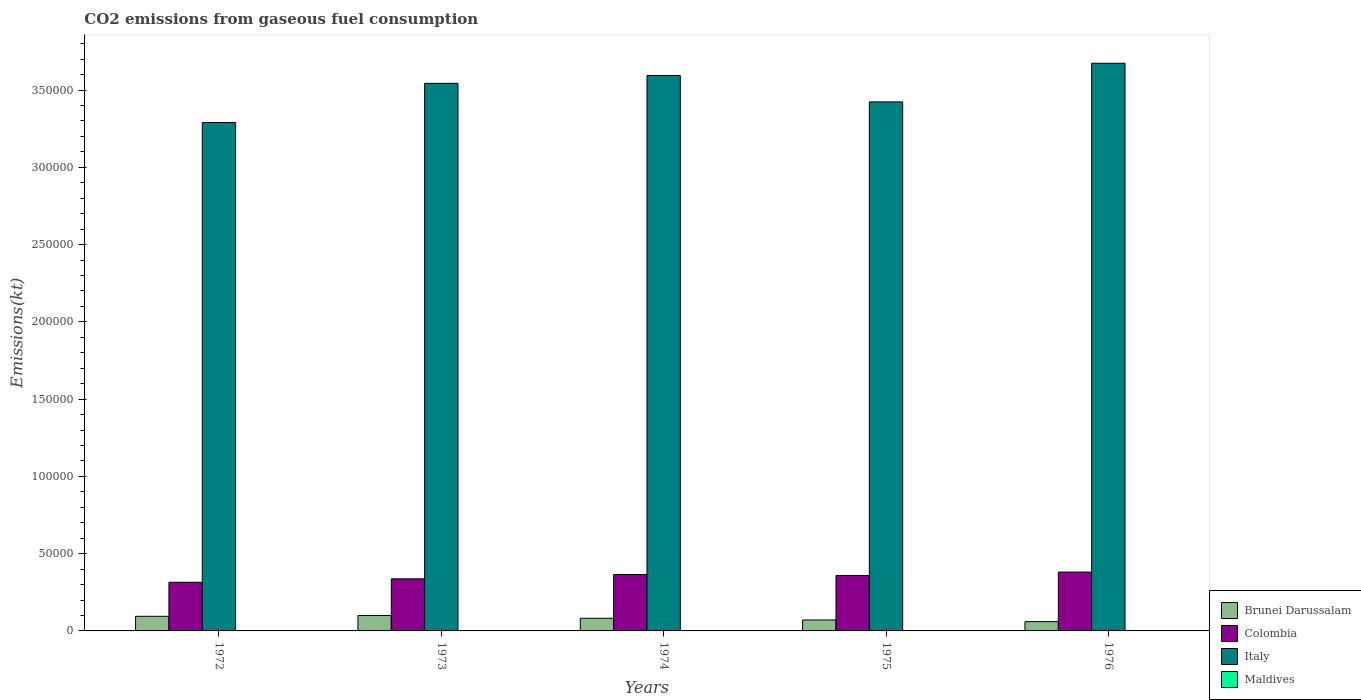How many different coloured bars are there?
Your answer should be very brief. 4. How many groups of bars are there?
Provide a succinct answer. 5. Are the number of bars on each tick of the X-axis equal?
Give a very brief answer. Yes. How many bars are there on the 2nd tick from the left?
Make the answer very short. 4. What is the label of the 5th group of bars from the left?
Offer a terse response. 1976. In how many cases, is the number of bars for a given year not equal to the number of legend labels?
Offer a terse response. 0. What is the amount of CO2 emitted in Brunei Darussalam in 1973?
Offer a very short reply. 9981.57. Across all years, what is the maximum amount of CO2 emitted in Maldives?
Provide a short and direct response. 11. Across all years, what is the minimum amount of CO2 emitted in Italy?
Provide a short and direct response. 3.29e+05. In which year was the amount of CO2 emitted in Maldives maximum?
Provide a short and direct response. 1976. In which year was the amount of CO2 emitted in Maldives minimum?
Your response must be concise. 1972. What is the total amount of CO2 emitted in Colombia in the graph?
Your answer should be very brief. 1.76e+05. What is the difference between the amount of CO2 emitted in Colombia in 1972 and that in 1974?
Your response must be concise. -4998.12. What is the difference between the amount of CO2 emitted in Italy in 1973 and the amount of CO2 emitted in Colombia in 1975?
Offer a very short reply. 3.18e+05. What is the average amount of CO2 emitted in Maldives per year?
Your response must be concise. 5.87. In the year 1975, what is the difference between the amount of CO2 emitted in Brunei Darussalam and amount of CO2 emitted in Italy?
Make the answer very short. -3.35e+05. What is the ratio of the amount of CO2 emitted in Italy in 1972 to that in 1974?
Offer a very short reply. 0.92. Is the amount of CO2 emitted in Maldives in 1973 less than that in 1975?
Your answer should be compact. Yes. Is the difference between the amount of CO2 emitted in Brunei Darussalam in 1973 and 1975 greater than the difference between the amount of CO2 emitted in Italy in 1973 and 1975?
Your answer should be compact. No. What is the difference between the highest and the second highest amount of CO2 emitted in Maldives?
Keep it short and to the point. 3.67. What is the difference between the highest and the lowest amount of CO2 emitted in Italy?
Ensure brevity in your answer.  3.83e+04. In how many years, is the amount of CO2 emitted in Maldives greater than the average amount of CO2 emitted in Maldives taken over all years?
Your answer should be very brief. 2. Is it the case that in every year, the sum of the amount of CO2 emitted in Italy and amount of CO2 emitted in Brunei Darussalam is greater than the sum of amount of CO2 emitted in Maldives and amount of CO2 emitted in Colombia?
Your answer should be very brief. No. What does the 1st bar from the left in 1976 represents?
Provide a succinct answer. Brunei Darussalam. What does the 4th bar from the right in 1974 represents?
Offer a very short reply. Brunei Darussalam. Are all the bars in the graph horizontal?
Ensure brevity in your answer.  No. How many years are there in the graph?
Offer a very short reply. 5. Are the values on the major ticks of Y-axis written in scientific E-notation?
Offer a very short reply. No. Does the graph contain any zero values?
Provide a short and direct response. No. Does the graph contain grids?
Your answer should be compact. No. Where does the legend appear in the graph?
Give a very brief answer. Bottom right. How many legend labels are there?
Offer a very short reply. 4. How are the legend labels stacked?
Make the answer very short. Vertical. What is the title of the graph?
Provide a succinct answer. CO2 emissions from gaseous fuel consumption. What is the label or title of the X-axis?
Provide a short and direct response. Years. What is the label or title of the Y-axis?
Your response must be concise. Emissions(kt). What is the Emissions(kt) of Brunei Darussalam in 1972?
Your answer should be compact. 9460.86. What is the Emissions(kt) of Colombia in 1972?
Give a very brief answer. 3.15e+04. What is the Emissions(kt) of Italy in 1972?
Offer a very short reply. 3.29e+05. What is the Emissions(kt) of Maldives in 1972?
Provide a succinct answer. 3.67. What is the Emissions(kt) in Brunei Darussalam in 1973?
Give a very brief answer. 9981.57. What is the Emissions(kt) in Colombia in 1973?
Your response must be concise. 3.37e+04. What is the Emissions(kt) of Italy in 1973?
Provide a short and direct response. 3.54e+05. What is the Emissions(kt) in Maldives in 1973?
Give a very brief answer. 3.67. What is the Emissions(kt) in Brunei Darussalam in 1974?
Give a very brief answer. 8184.74. What is the Emissions(kt) of Colombia in 1974?
Offer a very short reply. 3.65e+04. What is the Emissions(kt) in Italy in 1974?
Your response must be concise. 3.59e+05. What is the Emissions(kt) of Maldives in 1974?
Your response must be concise. 3.67. What is the Emissions(kt) in Brunei Darussalam in 1975?
Make the answer very short. 7080.98. What is the Emissions(kt) of Colombia in 1975?
Give a very brief answer. 3.59e+04. What is the Emissions(kt) in Italy in 1975?
Your answer should be compact. 3.42e+05. What is the Emissions(kt) in Maldives in 1975?
Provide a succinct answer. 7.33. What is the Emissions(kt) of Brunei Darussalam in 1976?
Provide a short and direct response. 6024.88. What is the Emissions(kt) of Colombia in 1976?
Keep it short and to the point. 3.81e+04. What is the Emissions(kt) in Italy in 1976?
Your response must be concise. 3.67e+05. What is the Emissions(kt) of Maldives in 1976?
Keep it short and to the point. 11. Across all years, what is the maximum Emissions(kt) in Brunei Darussalam?
Your answer should be compact. 9981.57. Across all years, what is the maximum Emissions(kt) in Colombia?
Ensure brevity in your answer.  3.81e+04. Across all years, what is the maximum Emissions(kt) in Italy?
Offer a terse response. 3.67e+05. Across all years, what is the maximum Emissions(kt) of Maldives?
Make the answer very short. 11. Across all years, what is the minimum Emissions(kt) of Brunei Darussalam?
Your response must be concise. 6024.88. Across all years, what is the minimum Emissions(kt) in Colombia?
Your response must be concise. 3.15e+04. Across all years, what is the minimum Emissions(kt) of Italy?
Keep it short and to the point. 3.29e+05. Across all years, what is the minimum Emissions(kt) in Maldives?
Give a very brief answer. 3.67. What is the total Emissions(kt) of Brunei Darussalam in the graph?
Ensure brevity in your answer.  4.07e+04. What is the total Emissions(kt) of Colombia in the graph?
Ensure brevity in your answer.  1.76e+05. What is the total Emissions(kt) of Italy in the graph?
Provide a succinct answer. 1.75e+06. What is the total Emissions(kt) of Maldives in the graph?
Your response must be concise. 29.34. What is the difference between the Emissions(kt) in Brunei Darussalam in 1972 and that in 1973?
Provide a short and direct response. -520.71. What is the difference between the Emissions(kt) in Colombia in 1972 and that in 1973?
Provide a short and direct response. -2218.53. What is the difference between the Emissions(kt) of Italy in 1972 and that in 1973?
Give a very brief answer. -2.53e+04. What is the difference between the Emissions(kt) in Brunei Darussalam in 1972 and that in 1974?
Keep it short and to the point. 1276.12. What is the difference between the Emissions(kt) of Colombia in 1972 and that in 1974?
Provide a succinct answer. -4998.12. What is the difference between the Emissions(kt) of Italy in 1972 and that in 1974?
Ensure brevity in your answer.  -3.04e+04. What is the difference between the Emissions(kt) of Maldives in 1972 and that in 1974?
Ensure brevity in your answer.  0. What is the difference between the Emissions(kt) in Brunei Darussalam in 1972 and that in 1975?
Ensure brevity in your answer.  2379.88. What is the difference between the Emissions(kt) in Colombia in 1972 and that in 1975?
Your answer should be compact. -4415.07. What is the difference between the Emissions(kt) in Italy in 1972 and that in 1975?
Your response must be concise. -1.33e+04. What is the difference between the Emissions(kt) of Maldives in 1972 and that in 1975?
Offer a very short reply. -3.67. What is the difference between the Emissions(kt) of Brunei Darussalam in 1972 and that in 1976?
Your response must be concise. 3435.98. What is the difference between the Emissions(kt) in Colombia in 1972 and that in 1976?
Offer a terse response. -6607.93. What is the difference between the Emissions(kt) of Italy in 1972 and that in 1976?
Provide a succinct answer. -3.83e+04. What is the difference between the Emissions(kt) in Maldives in 1972 and that in 1976?
Make the answer very short. -7.33. What is the difference between the Emissions(kt) of Brunei Darussalam in 1973 and that in 1974?
Offer a terse response. 1796.83. What is the difference between the Emissions(kt) in Colombia in 1973 and that in 1974?
Ensure brevity in your answer.  -2779.59. What is the difference between the Emissions(kt) in Italy in 1973 and that in 1974?
Your response must be concise. -5086.13. What is the difference between the Emissions(kt) in Brunei Darussalam in 1973 and that in 1975?
Your answer should be very brief. 2900.6. What is the difference between the Emissions(kt) in Colombia in 1973 and that in 1975?
Your answer should be compact. -2196.53. What is the difference between the Emissions(kt) of Italy in 1973 and that in 1975?
Give a very brief answer. 1.20e+04. What is the difference between the Emissions(kt) in Maldives in 1973 and that in 1975?
Provide a succinct answer. -3.67. What is the difference between the Emissions(kt) in Brunei Darussalam in 1973 and that in 1976?
Offer a very short reply. 3956.69. What is the difference between the Emissions(kt) in Colombia in 1973 and that in 1976?
Your answer should be very brief. -4389.4. What is the difference between the Emissions(kt) of Italy in 1973 and that in 1976?
Keep it short and to the point. -1.30e+04. What is the difference between the Emissions(kt) in Maldives in 1973 and that in 1976?
Your answer should be very brief. -7.33. What is the difference between the Emissions(kt) of Brunei Darussalam in 1974 and that in 1975?
Make the answer very short. 1103.77. What is the difference between the Emissions(kt) in Colombia in 1974 and that in 1975?
Your answer should be compact. 583.05. What is the difference between the Emissions(kt) of Italy in 1974 and that in 1975?
Make the answer very short. 1.71e+04. What is the difference between the Emissions(kt) of Maldives in 1974 and that in 1975?
Provide a succinct answer. -3.67. What is the difference between the Emissions(kt) in Brunei Darussalam in 1974 and that in 1976?
Keep it short and to the point. 2159.86. What is the difference between the Emissions(kt) of Colombia in 1974 and that in 1976?
Offer a very short reply. -1609.81. What is the difference between the Emissions(kt) of Italy in 1974 and that in 1976?
Your answer should be very brief. -7906.05. What is the difference between the Emissions(kt) of Maldives in 1974 and that in 1976?
Offer a terse response. -7.33. What is the difference between the Emissions(kt) of Brunei Darussalam in 1975 and that in 1976?
Ensure brevity in your answer.  1056.1. What is the difference between the Emissions(kt) in Colombia in 1975 and that in 1976?
Offer a very short reply. -2192.87. What is the difference between the Emissions(kt) of Italy in 1975 and that in 1976?
Make the answer very short. -2.50e+04. What is the difference between the Emissions(kt) in Maldives in 1975 and that in 1976?
Offer a very short reply. -3.67. What is the difference between the Emissions(kt) in Brunei Darussalam in 1972 and the Emissions(kt) in Colombia in 1973?
Keep it short and to the point. -2.42e+04. What is the difference between the Emissions(kt) in Brunei Darussalam in 1972 and the Emissions(kt) in Italy in 1973?
Make the answer very short. -3.45e+05. What is the difference between the Emissions(kt) in Brunei Darussalam in 1972 and the Emissions(kt) in Maldives in 1973?
Offer a terse response. 9457.19. What is the difference between the Emissions(kt) of Colombia in 1972 and the Emissions(kt) of Italy in 1973?
Your answer should be very brief. -3.23e+05. What is the difference between the Emissions(kt) of Colombia in 1972 and the Emissions(kt) of Maldives in 1973?
Your answer should be compact. 3.15e+04. What is the difference between the Emissions(kt) in Italy in 1972 and the Emissions(kt) in Maldives in 1973?
Ensure brevity in your answer.  3.29e+05. What is the difference between the Emissions(kt) in Brunei Darussalam in 1972 and the Emissions(kt) in Colombia in 1974?
Provide a succinct answer. -2.70e+04. What is the difference between the Emissions(kt) in Brunei Darussalam in 1972 and the Emissions(kt) in Italy in 1974?
Keep it short and to the point. -3.50e+05. What is the difference between the Emissions(kt) of Brunei Darussalam in 1972 and the Emissions(kt) of Maldives in 1974?
Provide a succinct answer. 9457.19. What is the difference between the Emissions(kt) in Colombia in 1972 and the Emissions(kt) in Italy in 1974?
Make the answer very short. -3.28e+05. What is the difference between the Emissions(kt) of Colombia in 1972 and the Emissions(kt) of Maldives in 1974?
Your answer should be compact. 3.15e+04. What is the difference between the Emissions(kt) of Italy in 1972 and the Emissions(kt) of Maldives in 1974?
Offer a very short reply. 3.29e+05. What is the difference between the Emissions(kt) in Brunei Darussalam in 1972 and the Emissions(kt) in Colombia in 1975?
Offer a very short reply. -2.64e+04. What is the difference between the Emissions(kt) in Brunei Darussalam in 1972 and the Emissions(kt) in Italy in 1975?
Offer a very short reply. -3.33e+05. What is the difference between the Emissions(kt) in Brunei Darussalam in 1972 and the Emissions(kt) in Maldives in 1975?
Your answer should be very brief. 9453.53. What is the difference between the Emissions(kt) in Colombia in 1972 and the Emissions(kt) in Italy in 1975?
Keep it short and to the point. -3.11e+05. What is the difference between the Emissions(kt) of Colombia in 1972 and the Emissions(kt) of Maldives in 1975?
Your answer should be compact. 3.15e+04. What is the difference between the Emissions(kt) of Italy in 1972 and the Emissions(kt) of Maldives in 1975?
Keep it short and to the point. 3.29e+05. What is the difference between the Emissions(kt) of Brunei Darussalam in 1972 and the Emissions(kt) of Colombia in 1976?
Keep it short and to the point. -2.86e+04. What is the difference between the Emissions(kt) of Brunei Darussalam in 1972 and the Emissions(kt) of Italy in 1976?
Offer a terse response. -3.58e+05. What is the difference between the Emissions(kt) of Brunei Darussalam in 1972 and the Emissions(kt) of Maldives in 1976?
Your response must be concise. 9449.86. What is the difference between the Emissions(kt) in Colombia in 1972 and the Emissions(kt) in Italy in 1976?
Provide a short and direct response. -3.36e+05. What is the difference between the Emissions(kt) of Colombia in 1972 and the Emissions(kt) of Maldives in 1976?
Make the answer very short. 3.15e+04. What is the difference between the Emissions(kt) in Italy in 1972 and the Emissions(kt) in Maldives in 1976?
Your response must be concise. 3.29e+05. What is the difference between the Emissions(kt) of Brunei Darussalam in 1973 and the Emissions(kt) of Colombia in 1974?
Make the answer very short. -2.65e+04. What is the difference between the Emissions(kt) of Brunei Darussalam in 1973 and the Emissions(kt) of Italy in 1974?
Provide a succinct answer. -3.49e+05. What is the difference between the Emissions(kt) in Brunei Darussalam in 1973 and the Emissions(kt) in Maldives in 1974?
Make the answer very short. 9977.91. What is the difference between the Emissions(kt) of Colombia in 1973 and the Emissions(kt) of Italy in 1974?
Offer a very short reply. -3.26e+05. What is the difference between the Emissions(kt) of Colombia in 1973 and the Emissions(kt) of Maldives in 1974?
Your answer should be very brief. 3.37e+04. What is the difference between the Emissions(kt) in Italy in 1973 and the Emissions(kt) in Maldives in 1974?
Offer a very short reply. 3.54e+05. What is the difference between the Emissions(kt) of Brunei Darussalam in 1973 and the Emissions(kt) of Colombia in 1975?
Give a very brief answer. -2.59e+04. What is the difference between the Emissions(kt) in Brunei Darussalam in 1973 and the Emissions(kt) in Italy in 1975?
Your response must be concise. -3.32e+05. What is the difference between the Emissions(kt) in Brunei Darussalam in 1973 and the Emissions(kt) in Maldives in 1975?
Provide a short and direct response. 9974.24. What is the difference between the Emissions(kt) in Colombia in 1973 and the Emissions(kt) in Italy in 1975?
Make the answer very short. -3.09e+05. What is the difference between the Emissions(kt) in Colombia in 1973 and the Emissions(kt) in Maldives in 1975?
Provide a short and direct response. 3.37e+04. What is the difference between the Emissions(kt) in Italy in 1973 and the Emissions(kt) in Maldives in 1975?
Give a very brief answer. 3.54e+05. What is the difference between the Emissions(kt) in Brunei Darussalam in 1973 and the Emissions(kt) in Colombia in 1976?
Your response must be concise. -2.81e+04. What is the difference between the Emissions(kt) in Brunei Darussalam in 1973 and the Emissions(kt) in Italy in 1976?
Give a very brief answer. -3.57e+05. What is the difference between the Emissions(kt) of Brunei Darussalam in 1973 and the Emissions(kt) of Maldives in 1976?
Offer a very short reply. 9970.57. What is the difference between the Emissions(kt) of Colombia in 1973 and the Emissions(kt) of Italy in 1976?
Provide a short and direct response. -3.34e+05. What is the difference between the Emissions(kt) of Colombia in 1973 and the Emissions(kt) of Maldives in 1976?
Provide a succinct answer. 3.37e+04. What is the difference between the Emissions(kt) in Italy in 1973 and the Emissions(kt) in Maldives in 1976?
Your answer should be compact. 3.54e+05. What is the difference between the Emissions(kt) in Brunei Darussalam in 1974 and the Emissions(kt) in Colombia in 1975?
Your response must be concise. -2.77e+04. What is the difference between the Emissions(kt) of Brunei Darussalam in 1974 and the Emissions(kt) of Italy in 1975?
Keep it short and to the point. -3.34e+05. What is the difference between the Emissions(kt) of Brunei Darussalam in 1974 and the Emissions(kt) of Maldives in 1975?
Your answer should be very brief. 8177.41. What is the difference between the Emissions(kt) of Colombia in 1974 and the Emissions(kt) of Italy in 1975?
Make the answer very short. -3.06e+05. What is the difference between the Emissions(kt) in Colombia in 1974 and the Emissions(kt) in Maldives in 1975?
Provide a short and direct response. 3.65e+04. What is the difference between the Emissions(kt) in Italy in 1974 and the Emissions(kt) in Maldives in 1975?
Provide a succinct answer. 3.59e+05. What is the difference between the Emissions(kt) in Brunei Darussalam in 1974 and the Emissions(kt) in Colombia in 1976?
Offer a terse response. -2.99e+04. What is the difference between the Emissions(kt) in Brunei Darussalam in 1974 and the Emissions(kt) in Italy in 1976?
Ensure brevity in your answer.  -3.59e+05. What is the difference between the Emissions(kt) in Brunei Darussalam in 1974 and the Emissions(kt) in Maldives in 1976?
Provide a succinct answer. 8173.74. What is the difference between the Emissions(kt) in Colombia in 1974 and the Emissions(kt) in Italy in 1976?
Provide a short and direct response. -3.31e+05. What is the difference between the Emissions(kt) in Colombia in 1974 and the Emissions(kt) in Maldives in 1976?
Provide a short and direct response. 3.65e+04. What is the difference between the Emissions(kt) in Italy in 1974 and the Emissions(kt) in Maldives in 1976?
Offer a terse response. 3.59e+05. What is the difference between the Emissions(kt) of Brunei Darussalam in 1975 and the Emissions(kt) of Colombia in 1976?
Your answer should be very brief. -3.10e+04. What is the difference between the Emissions(kt) in Brunei Darussalam in 1975 and the Emissions(kt) in Italy in 1976?
Ensure brevity in your answer.  -3.60e+05. What is the difference between the Emissions(kt) in Brunei Darussalam in 1975 and the Emissions(kt) in Maldives in 1976?
Offer a terse response. 7069.98. What is the difference between the Emissions(kt) of Colombia in 1975 and the Emissions(kt) of Italy in 1976?
Ensure brevity in your answer.  -3.31e+05. What is the difference between the Emissions(kt) in Colombia in 1975 and the Emissions(kt) in Maldives in 1976?
Ensure brevity in your answer.  3.59e+04. What is the difference between the Emissions(kt) of Italy in 1975 and the Emissions(kt) of Maldives in 1976?
Keep it short and to the point. 3.42e+05. What is the average Emissions(kt) of Brunei Darussalam per year?
Offer a very short reply. 8146.61. What is the average Emissions(kt) of Colombia per year?
Keep it short and to the point. 3.51e+04. What is the average Emissions(kt) of Italy per year?
Your answer should be compact. 3.50e+05. What is the average Emissions(kt) of Maldives per year?
Ensure brevity in your answer.  5.87. In the year 1972, what is the difference between the Emissions(kt) in Brunei Darussalam and Emissions(kt) in Colombia?
Your answer should be very brief. -2.20e+04. In the year 1972, what is the difference between the Emissions(kt) in Brunei Darussalam and Emissions(kt) in Italy?
Make the answer very short. -3.20e+05. In the year 1972, what is the difference between the Emissions(kt) of Brunei Darussalam and Emissions(kt) of Maldives?
Your answer should be very brief. 9457.19. In the year 1972, what is the difference between the Emissions(kt) in Colombia and Emissions(kt) in Italy?
Make the answer very short. -2.97e+05. In the year 1972, what is the difference between the Emissions(kt) in Colombia and Emissions(kt) in Maldives?
Provide a short and direct response. 3.15e+04. In the year 1972, what is the difference between the Emissions(kt) of Italy and Emissions(kt) of Maldives?
Keep it short and to the point. 3.29e+05. In the year 1973, what is the difference between the Emissions(kt) of Brunei Darussalam and Emissions(kt) of Colombia?
Your response must be concise. -2.37e+04. In the year 1973, what is the difference between the Emissions(kt) of Brunei Darussalam and Emissions(kt) of Italy?
Your response must be concise. -3.44e+05. In the year 1973, what is the difference between the Emissions(kt) of Brunei Darussalam and Emissions(kt) of Maldives?
Give a very brief answer. 9977.91. In the year 1973, what is the difference between the Emissions(kt) of Colombia and Emissions(kt) of Italy?
Ensure brevity in your answer.  -3.21e+05. In the year 1973, what is the difference between the Emissions(kt) in Colombia and Emissions(kt) in Maldives?
Ensure brevity in your answer.  3.37e+04. In the year 1973, what is the difference between the Emissions(kt) of Italy and Emissions(kt) of Maldives?
Give a very brief answer. 3.54e+05. In the year 1974, what is the difference between the Emissions(kt) in Brunei Darussalam and Emissions(kt) in Colombia?
Your answer should be compact. -2.83e+04. In the year 1974, what is the difference between the Emissions(kt) in Brunei Darussalam and Emissions(kt) in Italy?
Your answer should be very brief. -3.51e+05. In the year 1974, what is the difference between the Emissions(kt) of Brunei Darussalam and Emissions(kt) of Maldives?
Your answer should be compact. 8181.08. In the year 1974, what is the difference between the Emissions(kt) in Colombia and Emissions(kt) in Italy?
Keep it short and to the point. -3.23e+05. In the year 1974, what is the difference between the Emissions(kt) of Colombia and Emissions(kt) of Maldives?
Keep it short and to the point. 3.65e+04. In the year 1974, what is the difference between the Emissions(kt) of Italy and Emissions(kt) of Maldives?
Ensure brevity in your answer.  3.59e+05. In the year 1975, what is the difference between the Emissions(kt) of Brunei Darussalam and Emissions(kt) of Colombia?
Keep it short and to the point. -2.88e+04. In the year 1975, what is the difference between the Emissions(kt) of Brunei Darussalam and Emissions(kt) of Italy?
Your answer should be very brief. -3.35e+05. In the year 1975, what is the difference between the Emissions(kt) of Brunei Darussalam and Emissions(kt) of Maldives?
Offer a terse response. 7073.64. In the year 1975, what is the difference between the Emissions(kt) of Colombia and Emissions(kt) of Italy?
Offer a terse response. -3.06e+05. In the year 1975, what is the difference between the Emissions(kt) of Colombia and Emissions(kt) of Maldives?
Offer a terse response. 3.59e+04. In the year 1975, what is the difference between the Emissions(kt) in Italy and Emissions(kt) in Maldives?
Your answer should be compact. 3.42e+05. In the year 1976, what is the difference between the Emissions(kt) of Brunei Darussalam and Emissions(kt) of Colombia?
Your answer should be very brief. -3.21e+04. In the year 1976, what is the difference between the Emissions(kt) of Brunei Darussalam and Emissions(kt) of Italy?
Offer a terse response. -3.61e+05. In the year 1976, what is the difference between the Emissions(kt) in Brunei Darussalam and Emissions(kt) in Maldives?
Provide a succinct answer. 6013.88. In the year 1976, what is the difference between the Emissions(kt) in Colombia and Emissions(kt) in Italy?
Keep it short and to the point. -3.29e+05. In the year 1976, what is the difference between the Emissions(kt) in Colombia and Emissions(kt) in Maldives?
Offer a very short reply. 3.81e+04. In the year 1976, what is the difference between the Emissions(kt) of Italy and Emissions(kt) of Maldives?
Keep it short and to the point. 3.67e+05. What is the ratio of the Emissions(kt) in Brunei Darussalam in 1972 to that in 1973?
Provide a succinct answer. 0.95. What is the ratio of the Emissions(kt) of Colombia in 1972 to that in 1973?
Offer a terse response. 0.93. What is the ratio of the Emissions(kt) of Italy in 1972 to that in 1973?
Offer a very short reply. 0.93. What is the ratio of the Emissions(kt) of Brunei Darussalam in 1972 to that in 1974?
Offer a terse response. 1.16. What is the ratio of the Emissions(kt) in Colombia in 1972 to that in 1974?
Give a very brief answer. 0.86. What is the ratio of the Emissions(kt) in Italy in 1972 to that in 1974?
Give a very brief answer. 0.92. What is the ratio of the Emissions(kt) of Brunei Darussalam in 1972 to that in 1975?
Ensure brevity in your answer.  1.34. What is the ratio of the Emissions(kt) of Colombia in 1972 to that in 1975?
Give a very brief answer. 0.88. What is the ratio of the Emissions(kt) in Brunei Darussalam in 1972 to that in 1976?
Your response must be concise. 1.57. What is the ratio of the Emissions(kt) in Colombia in 1972 to that in 1976?
Give a very brief answer. 0.83. What is the ratio of the Emissions(kt) of Italy in 1972 to that in 1976?
Keep it short and to the point. 0.9. What is the ratio of the Emissions(kt) in Brunei Darussalam in 1973 to that in 1974?
Offer a very short reply. 1.22. What is the ratio of the Emissions(kt) in Colombia in 1973 to that in 1974?
Your answer should be very brief. 0.92. What is the ratio of the Emissions(kt) of Italy in 1973 to that in 1974?
Ensure brevity in your answer.  0.99. What is the ratio of the Emissions(kt) in Brunei Darussalam in 1973 to that in 1975?
Offer a terse response. 1.41. What is the ratio of the Emissions(kt) of Colombia in 1973 to that in 1975?
Give a very brief answer. 0.94. What is the ratio of the Emissions(kt) of Italy in 1973 to that in 1975?
Your response must be concise. 1.04. What is the ratio of the Emissions(kt) in Maldives in 1973 to that in 1975?
Give a very brief answer. 0.5. What is the ratio of the Emissions(kt) in Brunei Darussalam in 1973 to that in 1976?
Provide a succinct answer. 1.66. What is the ratio of the Emissions(kt) in Colombia in 1973 to that in 1976?
Provide a short and direct response. 0.88. What is the ratio of the Emissions(kt) in Italy in 1973 to that in 1976?
Offer a very short reply. 0.96. What is the ratio of the Emissions(kt) of Brunei Darussalam in 1974 to that in 1975?
Your response must be concise. 1.16. What is the ratio of the Emissions(kt) of Colombia in 1974 to that in 1975?
Your response must be concise. 1.02. What is the ratio of the Emissions(kt) of Italy in 1974 to that in 1975?
Your answer should be very brief. 1.05. What is the ratio of the Emissions(kt) in Brunei Darussalam in 1974 to that in 1976?
Give a very brief answer. 1.36. What is the ratio of the Emissions(kt) of Colombia in 1974 to that in 1976?
Your answer should be very brief. 0.96. What is the ratio of the Emissions(kt) in Italy in 1974 to that in 1976?
Offer a terse response. 0.98. What is the ratio of the Emissions(kt) in Brunei Darussalam in 1975 to that in 1976?
Provide a succinct answer. 1.18. What is the ratio of the Emissions(kt) of Colombia in 1975 to that in 1976?
Your answer should be compact. 0.94. What is the ratio of the Emissions(kt) of Italy in 1975 to that in 1976?
Provide a succinct answer. 0.93. What is the difference between the highest and the second highest Emissions(kt) of Brunei Darussalam?
Keep it short and to the point. 520.71. What is the difference between the highest and the second highest Emissions(kt) in Colombia?
Give a very brief answer. 1609.81. What is the difference between the highest and the second highest Emissions(kt) of Italy?
Offer a terse response. 7906.05. What is the difference between the highest and the second highest Emissions(kt) in Maldives?
Make the answer very short. 3.67. What is the difference between the highest and the lowest Emissions(kt) in Brunei Darussalam?
Make the answer very short. 3956.69. What is the difference between the highest and the lowest Emissions(kt) of Colombia?
Ensure brevity in your answer.  6607.93. What is the difference between the highest and the lowest Emissions(kt) of Italy?
Provide a short and direct response. 3.83e+04. What is the difference between the highest and the lowest Emissions(kt) in Maldives?
Give a very brief answer. 7.33. 